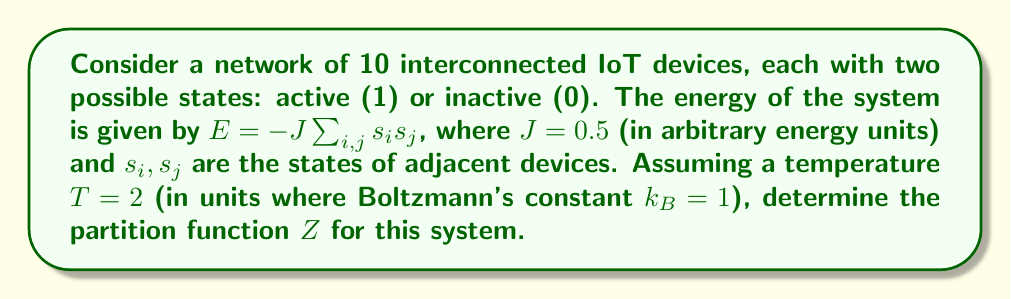Give your solution to this math problem. To solve this problem, we'll follow these steps:

1) The partition function is given by:
   $$Z = \sum_{\text{all states}} e^{-\beta E}$$
   where $\beta = \frac{1}{k_B T}$

2) In this case, $\beta = \frac{1}{2}$ (since $T = 2$ and $k_B = 1$)

3) For 10 devices, there are $2^{10} = 1024$ possible states

4) The energy $E = -J\sum_{i,j} s_i s_j$ depends on the configuration of states

5) To calculate $Z$, we need to sum $e^{-\beta E}$ over all 1024 states:
   $$Z = \sum_{s_1=0,1} \sum_{s_2=0,1} ... \sum_{s_{10}=0,1} \exp\left(\frac{J}{2}\sum_{i,j} s_i s_j\right)$$

6) This sum is computationally intensive and typically requires numerical methods or approximations for large systems

7) For a simplified example, let's consider a fully connected network where each device interacts with every other device. In this case:
   $$E = -J\cdot \frac{N(N-1)}{2} \cdot (\frac{n_1}{N} - \frac{n_0}{N})^2$$
   where $N = 10$ is the total number of devices, $n_1$ is the number of active devices, and $n_0 = N - n_1$

8) The partition function then becomes:
   $$Z = \sum_{n_1=0}^{10} \binom{10}{n_1} \exp\left(\frac{J}{4T} \cdot 90 \cdot (\frac{2n_1}{10} - 1)^2\right)$$

9) Evaluating this sum (which can be done numerically) gives the final result for $Z$

Note: The actual value would depend on the specific network topology and interactions, which would require more detailed information or computational methods to solve precisely.
Answer: $Z = \sum_{n_1=0}^{10} \binom{10}{n_1} \exp\left(\frac{45}{4} \cdot (\frac{2n_1}{10} - 1)^2\right)$ 